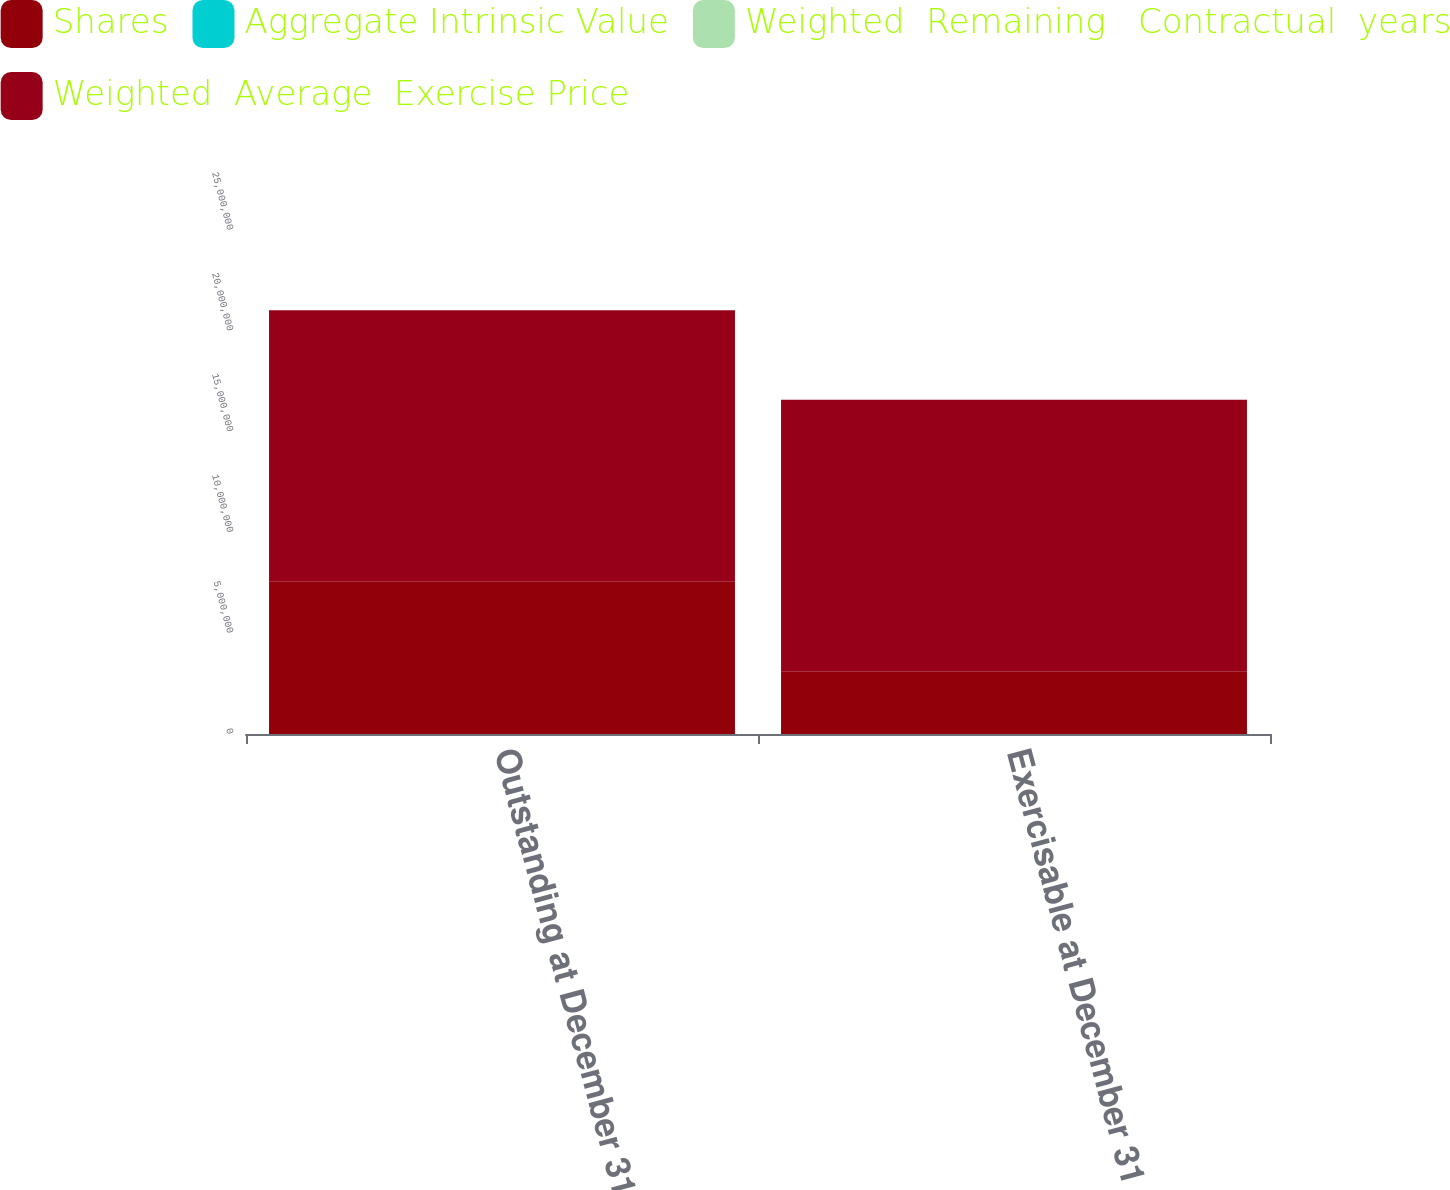Convert chart. <chart><loc_0><loc_0><loc_500><loc_500><stacked_bar_chart><ecel><fcel>Outstanding at December 31<fcel>Exercisable at December 31<nl><fcel>Shares<fcel>7.54782e+06<fcel>3.11046e+06<nl><fcel>Aggregate Intrinsic Value<fcel>37.24<fcel>26.17<nl><fcel>Weighted  Remaining   Contractual  years<fcel>7.25<fcel>5.9<nl><fcel>Weighted  Average  Exercise Price<fcel>1.34737e+07<fcel>1.34737e+07<nl></chart> 